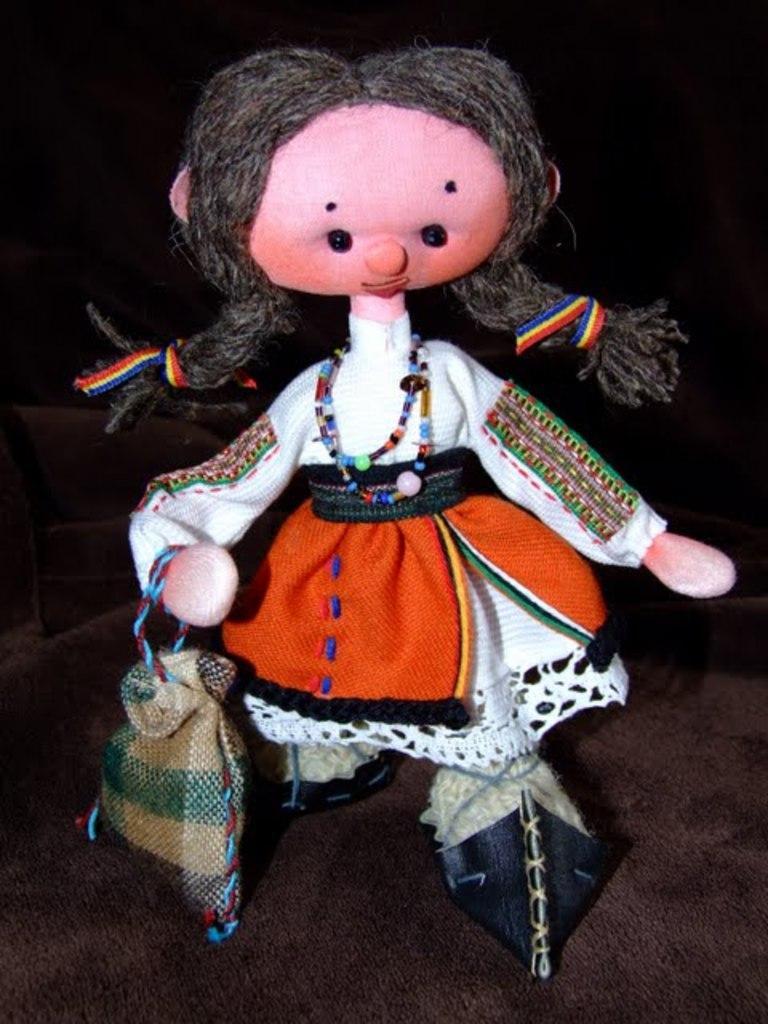Describe this image in one or two sentences. In this image we can see a doll placed on the surface. 